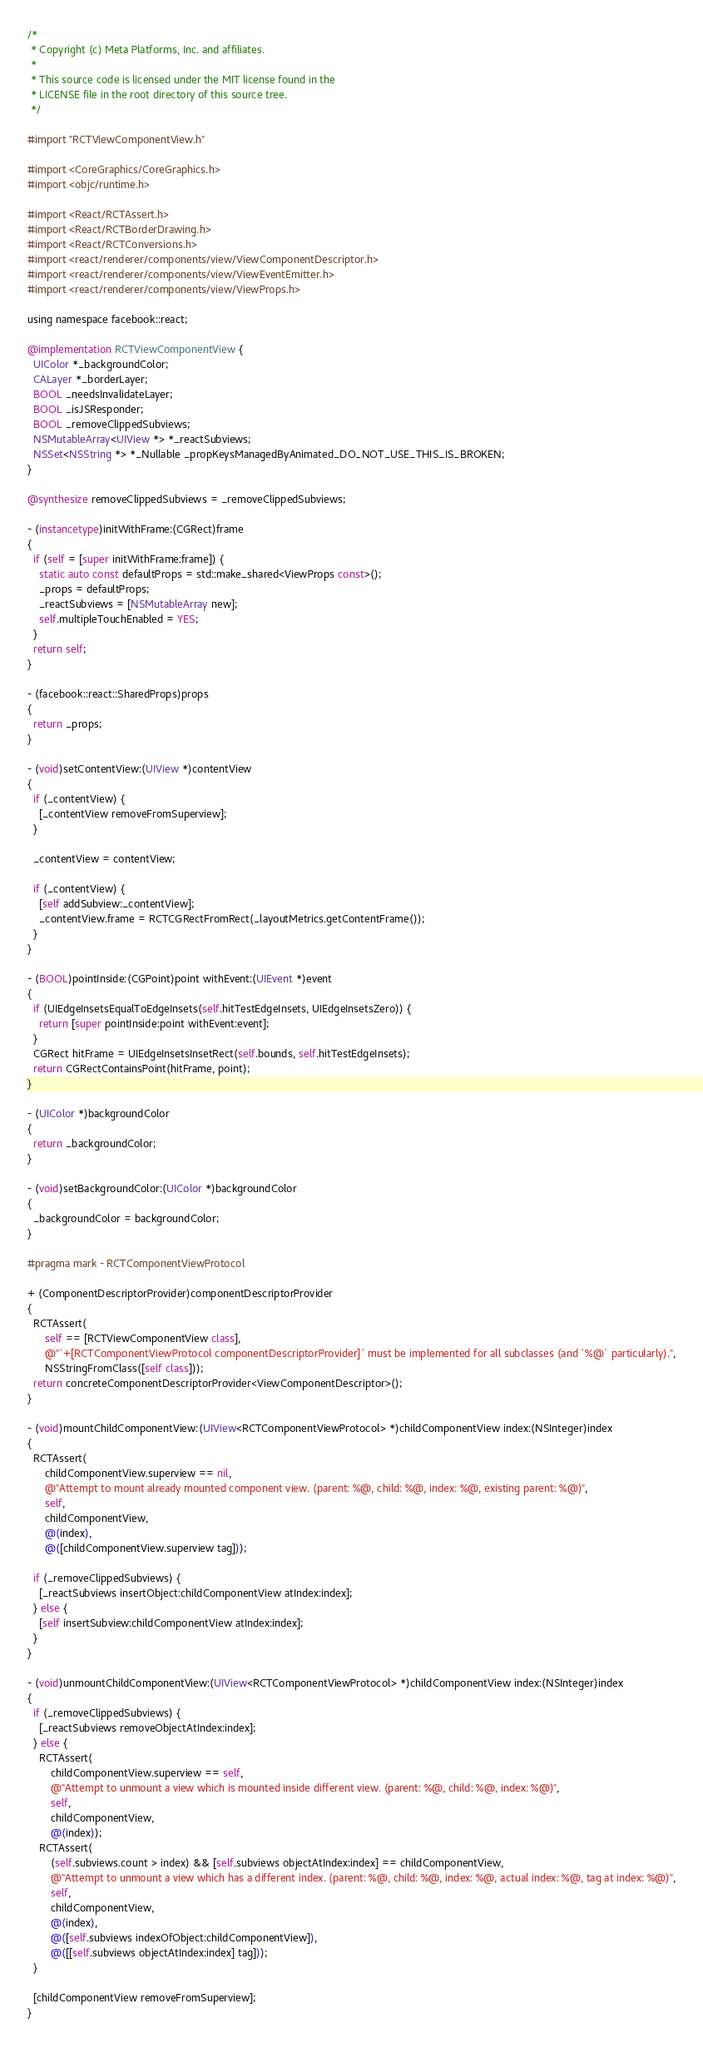<code> <loc_0><loc_0><loc_500><loc_500><_ObjectiveC_>/*
 * Copyright (c) Meta Platforms, Inc. and affiliates.
 *
 * This source code is licensed under the MIT license found in the
 * LICENSE file in the root directory of this source tree.
 */

#import "RCTViewComponentView.h"

#import <CoreGraphics/CoreGraphics.h>
#import <objc/runtime.h>

#import <React/RCTAssert.h>
#import <React/RCTBorderDrawing.h>
#import <React/RCTConversions.h>
#import <react/renderer/components/view/ViewComponentDescriptor.h>
#import <react/renderer/components/view/ViewEventEmitter.h>
#import <react/renderer/components/view/ViewProps.h>

using namespace facebook::react;

@implementation RCTViewComponentView {
  UIColor *_backgroundColor;
  CALayer *_borderLayer;
  BOOL _needsInvalidateLayer;
  BOOL _isJSResponder;
  BOOL _removeClippedSubviews;
  NSMutableArray<UIView *> *_reactSubviews;
  NSSet<NSString *> *_Nullable _propKeysManagedByAnimated_DO_NOT_USE_THIS_IS_BROKEN;
}

@synthesize removeClippedSubviews = _removeClippedSubviews;

- (instancetype)initWithFrame:(CGRect)frame
{
  if (self = [super initWithFrame:frame]) {
    static auto const defaultProps = std::make_shared<ViewProps const>();
    _props = defaultProps;
    _reactSubviews = [NSMutableArray new];
    self.multipleTouchEnabled = YES;
  }
  return self;
}

- (facebook::react::SharedProps)props
{
  return _props;
}

- (void)setContentView:(UIView *)contentView
{
  if (_contentView) {
    [_contentView removeFromSuperview];
  }

  _contentView = contentView;

  if (_contentView) {
    [self addSubview:_contentView];
    _contentView.frame = RCTCGRectFromRect(_layoutMetrics.getContentFrame());
  }
}

- (BOOL)pointInside:(CGPoint)point withEvent:(UIEvent *)event
{
  if (UIEdgeInsetsEqualToEdgeInsets(self.hitTestEdgeInsets, UIEdgeInsetsZero)) {
    return [super pointInside:point withEvent:event];
  }
  CGRect hitFrame = UIEdgeInsetsInsetRect(self.bounds, self.hitTestEdgeInsets);
  return CGRectContainsPoint(hitFrame, point);
}

- (UIColor *)backgroundColor
{
  return _backgroundColor;
}

- (void)setBackgroundColor:(UIColor *)backgroundColor
{
  _backgroundColor = backgroundColor;
}

#pragma mark - RCTComponentViewProtocol

+ (ComponentDescriptorProvider)componentDescriptorProvider
{
  RCTAssert(
      self == [RCTViewComponentView class],
      @"`+[RCTComponentViewProtocol componentDescriptorProvider]` must be implemented for all subclasses (and `%@` particularly).",
      NSStringFromClass([self class]));
  return concreteComponentDescriptorProvider<ViewComponentDescriptor>();
}

- (void)mountChildComponentView:(UIView<RCTComponentViewProtocol> *)childComponentView index:(NSInteger)index
{
  RCTAssert(
      childComponentView.superview == nil,
      @"Attempt to mount already mounted component view. (parent: %@, child: %@, index: %@, existing parent: %@)",
      self,
      childComponentView,
      @(index),
      @([childComponentView.superview tag]));

  if (_removeClippedSubviews) {
    [_reactSubviews insertObject:childComponentView atIndex:index];
  } else {
    [self insertSubview:childComponentView atIndex:index];
  }
}

- (void)unmountChildComponentView:(UIView<RCTComponentViewProtocol> *)childComponentView index:(NSInteger)index
{
  if (_removeClippedSubviews) {
    [_reactSubviews removeObjectAtIndex:index];
  } else {
    RCTAssert(
        childComponentView.superview == self,
        @"Attempt to unmount a view which is mounted inside different view. (parent: %@, child: %@, index: %@)",
        self,
        childComponentView,
        @(index));
    RCTAssert(
        (self.subviews.count > index) && [self.subviews objectAtIndex:index] == childComponentView,
        @"Attempt to unmount a view which has a different index. (parent: %@, child: %@, index: %@, actual index: %@, tag at index: %@)",
        self,
        childComponentView,
        @(index),
        @([self.subviews indexOfObject:childComponentView]),
        @([[self.subviews objectAtIndex:index] tag]));
  }

  [childComponentView removeFromSuperview];
}
</code> 